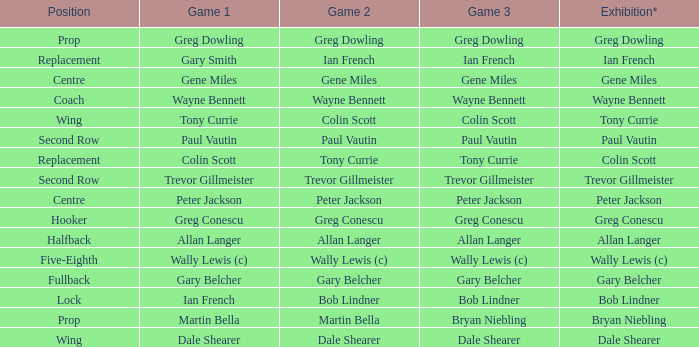Wjat game 3 has ian french as a game of 2? Ian French. 